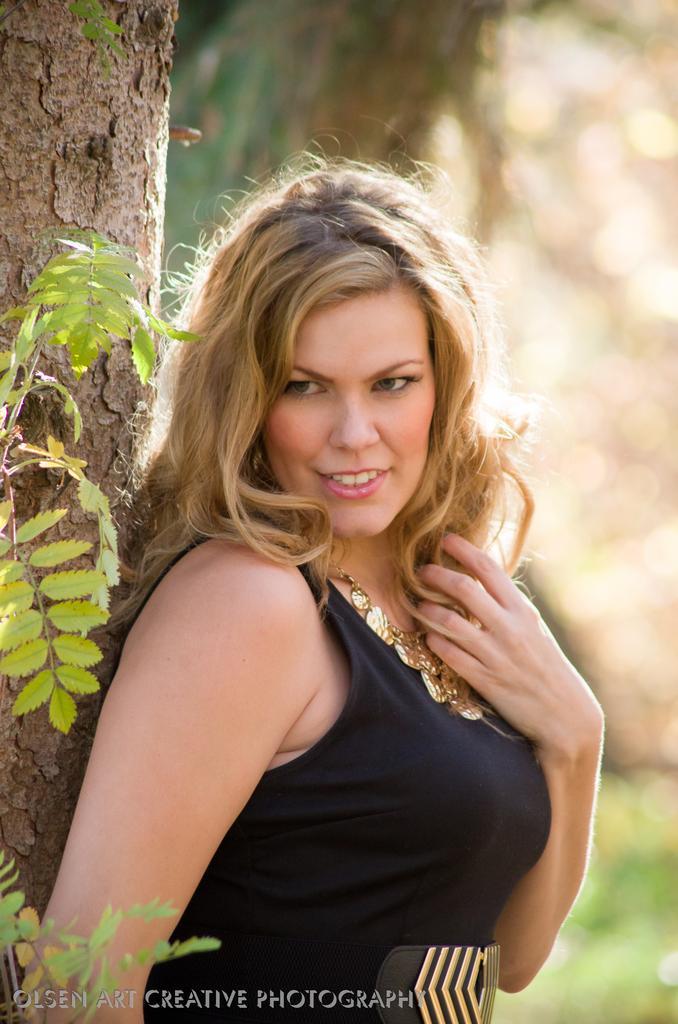Can you describe this image briefly? This image is taken outdoors. In this image the background is a little blurred. On the left side of the image there is a tree. In the middle of the image a woman is standing and she is with a smiling face. 